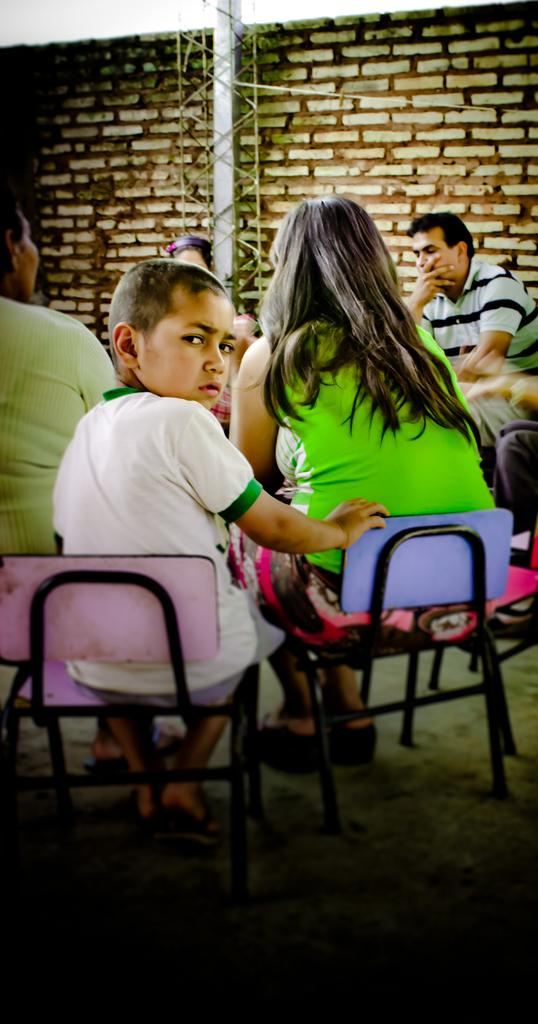What is the main subject of the image? The main subject of the image is a group of people. What are the people in the image doing? The people are seated on chairs in the image. Can you describe the boy in the image? There is a boy in the image, and he is looking back. What type of rod is the boy holding in the image? There is no rod present in the image; the boy is not holding anything. Can you describe the pet that is sitting next to the boy in the image? There is no pet present in the image; only the group of people is visible. 